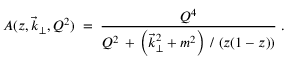<formula> <loc_0><loc_0><loc_500><loc_500>A ( z , \vec { k } _ { \perp } , Q ^ { 2 } ) \, = \, \frac { Q ^ { 4 } } { Q ^ { 2 } \, + \, \left ( \vec { k } _ { \perp } ^ { 2 } + m ^ { 2 } \right ) \, / \, \left ( z ( 1 - z ) \right ) } \, .</formula> 